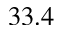<formula> <loc_0><loc_0><loc_500><loc_500>3 3 . 4</formula> 